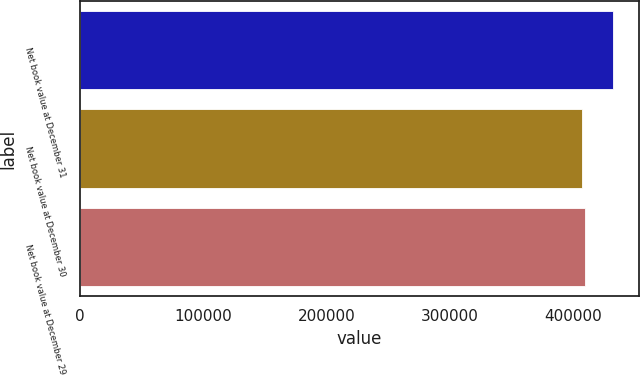Convert chart. <chart><loc_0><loc_0><loc_500><loc_500><bar_chart><fcel>Net book value at December 31<fcel>Net book value at December 30<fcel>Net book value at December 29<nl><fcel>431561<fcel>406853<fcel>409324<nl></chart> 